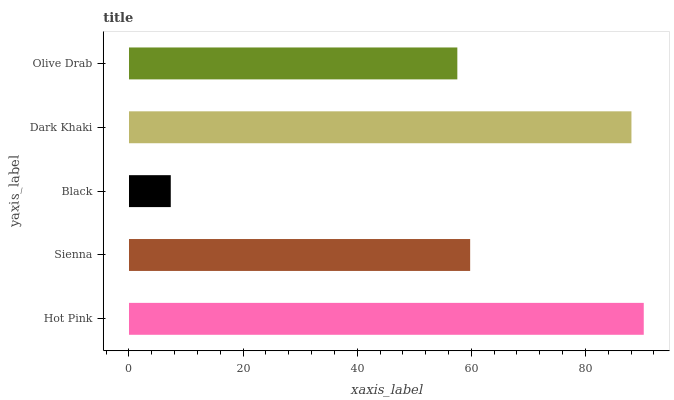Is Black the minimum?
Answer yes or no. Yes. Is Hot Pink the maximum?
Answer yes or no. Yes. Is Sienna the minimum?
Answer yes or no. No. Is Sienna the maximum?
Answer yes or no. No. Is Hot Pink greater than Sienna?
Answer yes or no. Yes. Is Sienna less than Hot Pink?
Answer yes or no. Yes. Is Sienna greater than Hot Pink?
Answer yes or no. No. Is Hot Pink less than Sienna?
Answer yes or no. No. Is Sienna the high median?
Answer yes or no. Yes. Is Sienna the low median?
Answer yes or no. Yes. Is Olive Drab the high median?
Answer yes or no. No. Is Black the low median?
Answer yes or no. No. 